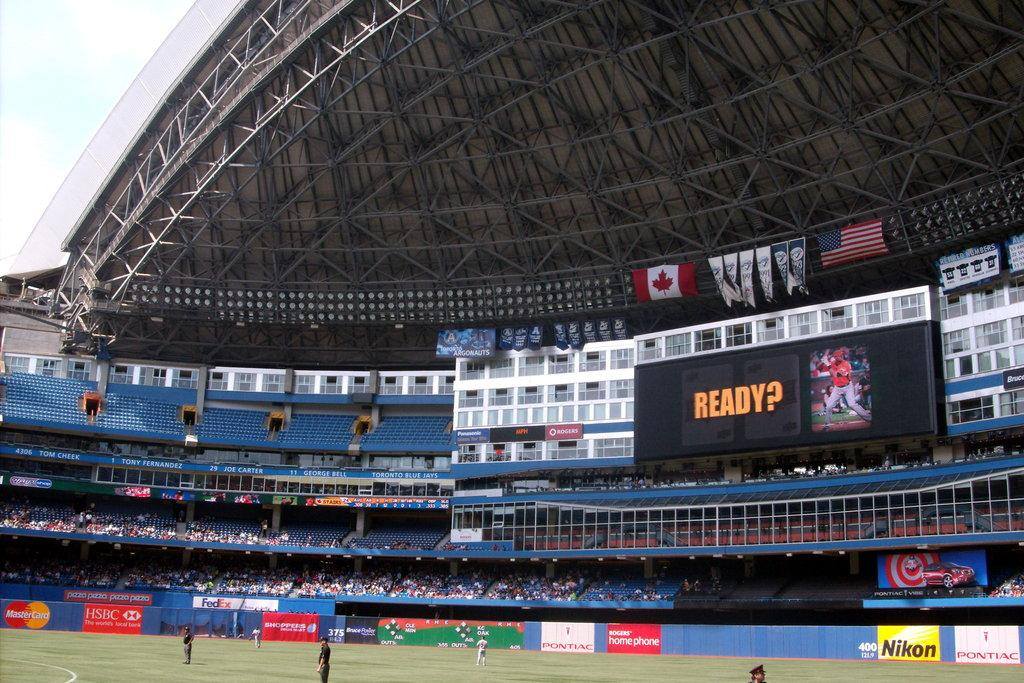<image>
Summarize the visual content of the image. Baseball stadium that is empty and has the word Ready on screen. 